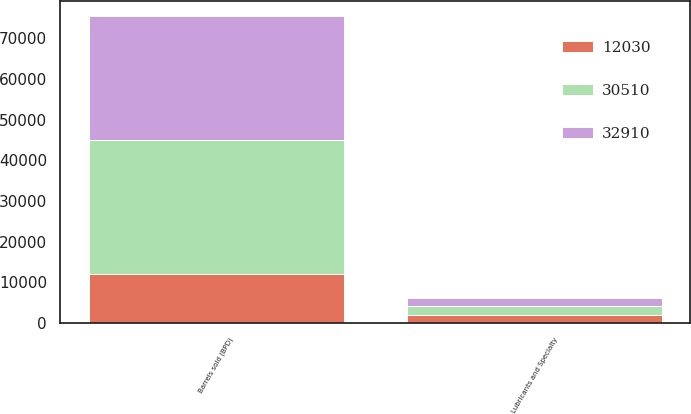<chart> <loc_0><loc_0><loc_500><loc_500><stacked_bar_chart><ecel><fcel>Lubricants and Specialty<fcel>Barrels sold (BPD)<nl><fcel>32910<fcel>2018<fcel>30510<nl><fcel>30510<fcel>2017<fcel>32910<nl><fcel>12030<fcel>2016<fcel>12030<nl></chart> 